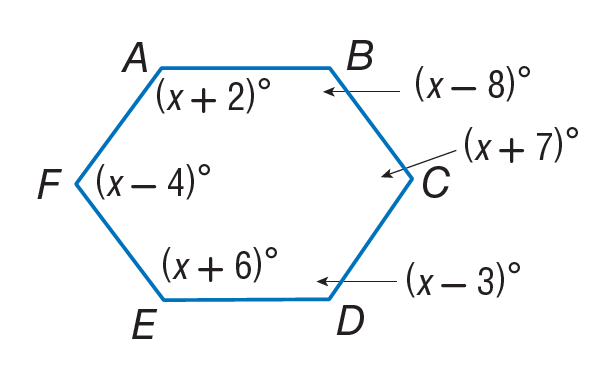Answer the mathemtical geometry problem and directly provide the correct option letter.
Question: Find m \angle D.
Choices: A: 117 B: 117 C: 126 D: 127 A 